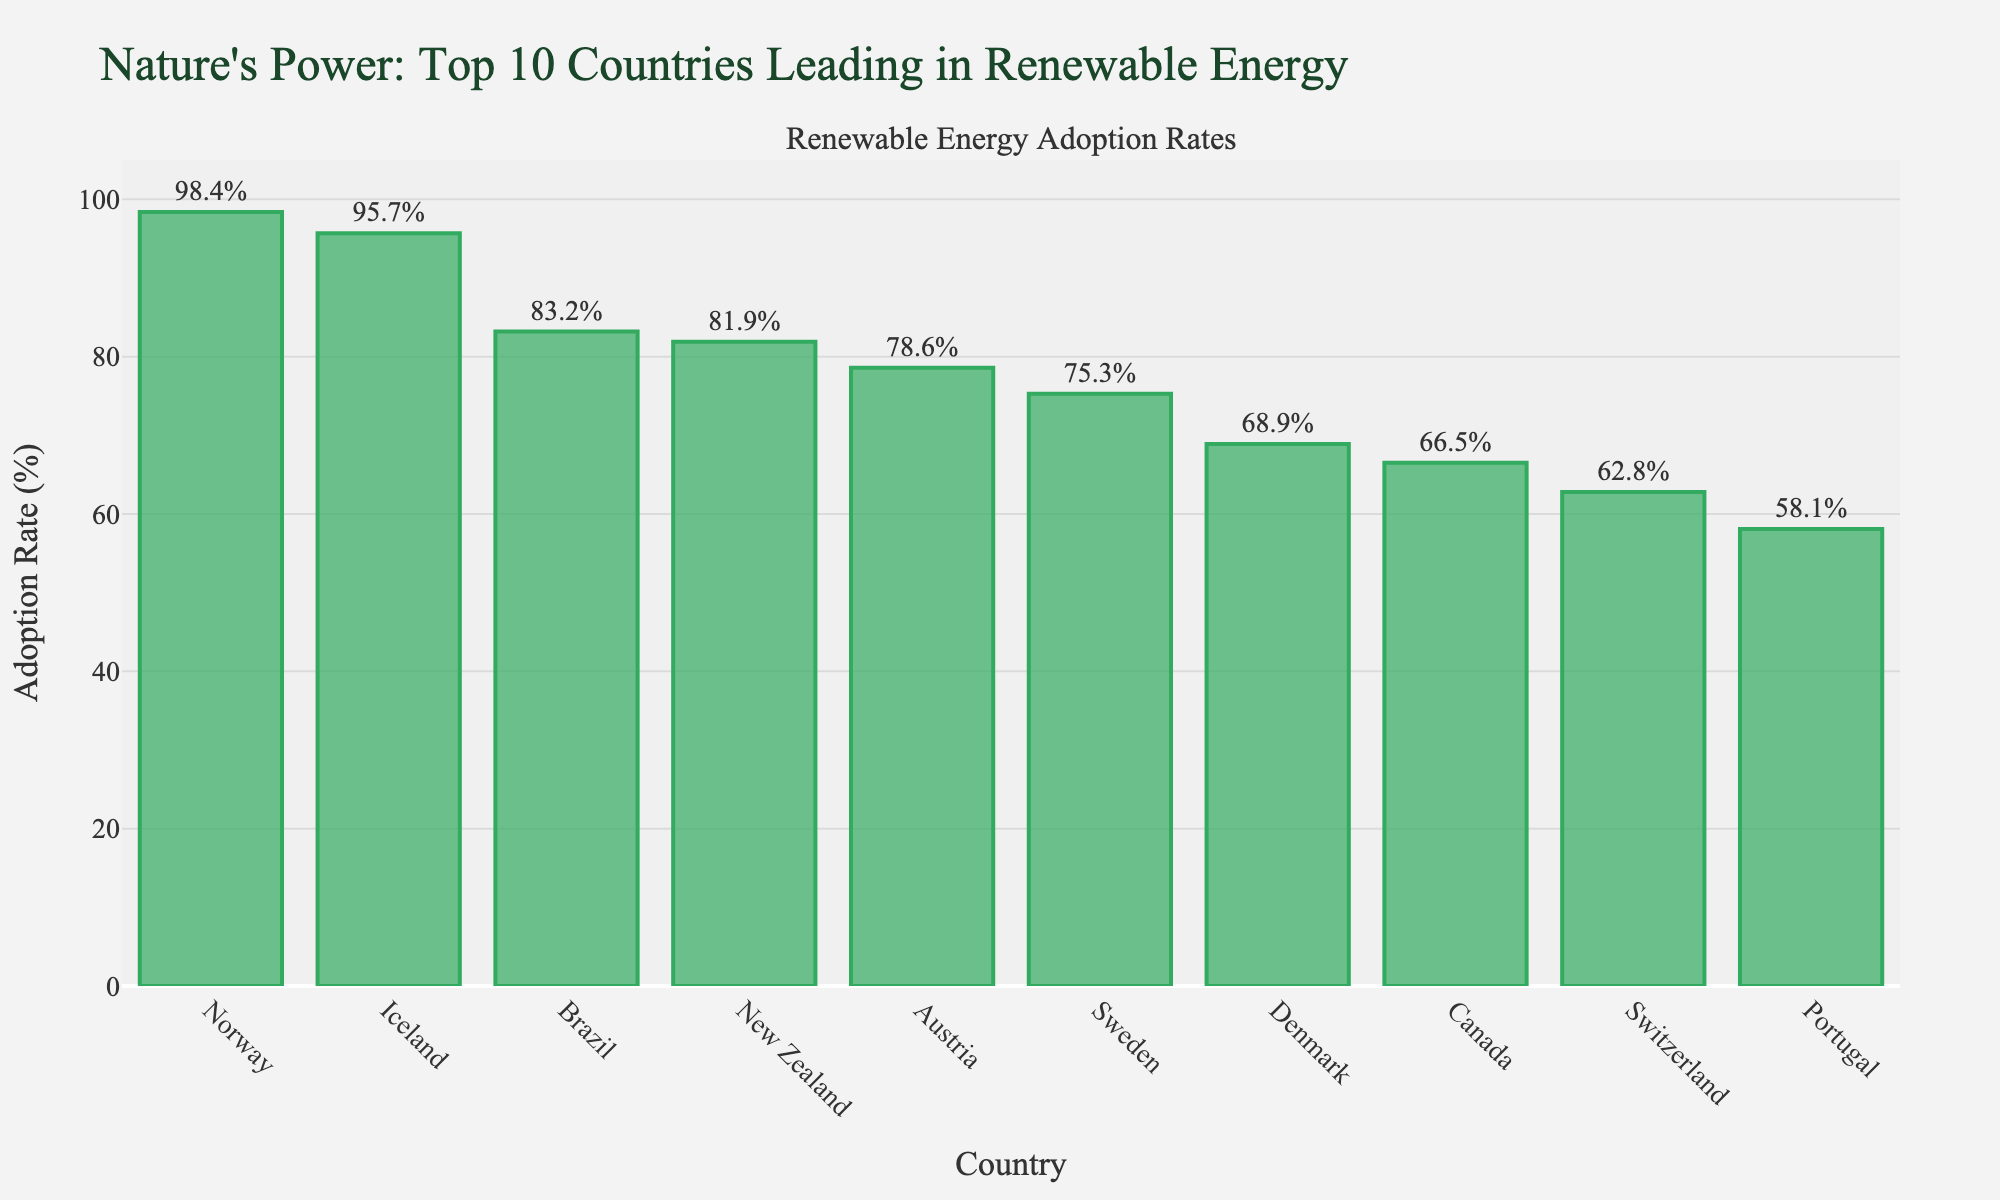What's the highest renewable energy adoption rate? The highest renewable energy adoption rate is shown by the height of the bar representing Norway. Norway's bar is the tallest and its text label indicates 98.4%.
Answer: 98.4% Which country has the lowest renewable energy adoption rate among the top 10? The lowest renewable energy adoption rate is indicated by the shortest bar in the chart. Portugal has the shortest bar with a text label showing 58.1%.
Answer: Portugal How much higher is Norway's adoption rate compared to Sweden's? Norway's adoption rate is 98.4% and Sweden's is 75.3%. The difference is calculated as 98.4 - 75.3, which equals 23.1%.
Answer: 23.1% What is the average renewable energy adoption rate of the top 5 countries? The top 5 countries are Norway, Iceland, Brazil, New Zealand, and Austria with adoption rates of 98.4%, 95.7%, 83.2%, 81.9%, and 78.6% respectively. The average is calculated as (98.4 + 95.7 + 83.2 + 81.9 + 78.6) / 5, which equals 87.56%.
Answer: 87.56% Which countries have adoption rates above 80%? By inspecting the bars, Norway, Iceland, Brazil, and New Zealand have text labels indicating adoption rates above 80%. Their respective rates are 98.4%, 95.7%, 83.2%, and 81.9%.
Answer: Norway, Iceland, Brazil, New Zealand What is the median renewable energy adoption rate for these 10 countries? To find the median, the adoption rates have to be listed in numerical order: 58.1, 62.8, 66.5, 68.9, 75.3, 78.6, 81.9, 83.2, 95.7, 98.4. The median value, being the 5th and 6th entries averaged, is (75.3 + 78.6)/2, which equals 76.95%.
Answer: 76.95% Are there more countries with adoption rates above or below 70%? Upon inspecting the bars, the countries with rates above 70% are Norway, Iceland, Brazil, New Zealand, Austria, and Sweden (6 countries). The countries below 70% are Denmark, Canada, Switzerland, and Portugal (4 countries). Therefore, there are more countries above 70%.
Answer: Above What is the total adoption rate of the top 3 countries combined? The top 3 countries by adoption rates are Norway (98.4%), Iceland (95.7%), and Brazil (83.2%). The total adoption rate is the sum: 98.4 + 95.7 + 83.2 = 277.3%.
Answer: 277.3% Which country's renewable energy adoption rate is closest to 60%? By looking at the bars, Switzerland has an adoption rate of 62.8%, which is closest to 60%.
Answer: Switzerland How many countries have a renewable energy adoption rate that is more than double that of Portugal? Portugal's rate is 58.1%. More than double this rate is 116.2%. Since none of the listed countries have an adoption rate higher than 100%, no countries meet this criterion.
Answer: 0 